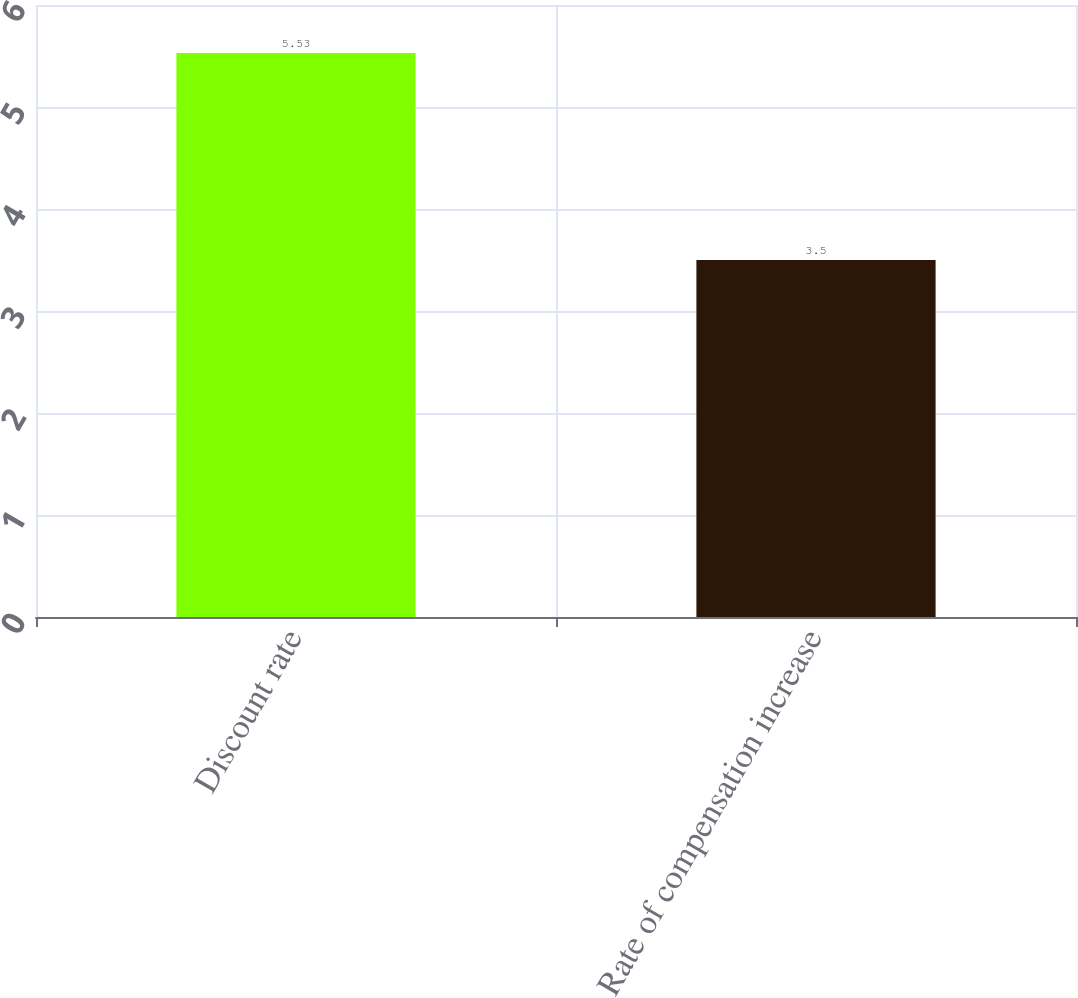Convert chart. <chart><loc_0><loc_0><loc_500><loc_500><bar_chart><fcel>Discount rate<fcel>Rate of compensation increase<nl><fcel>5.53<fcel>3.5<nl></chart> 